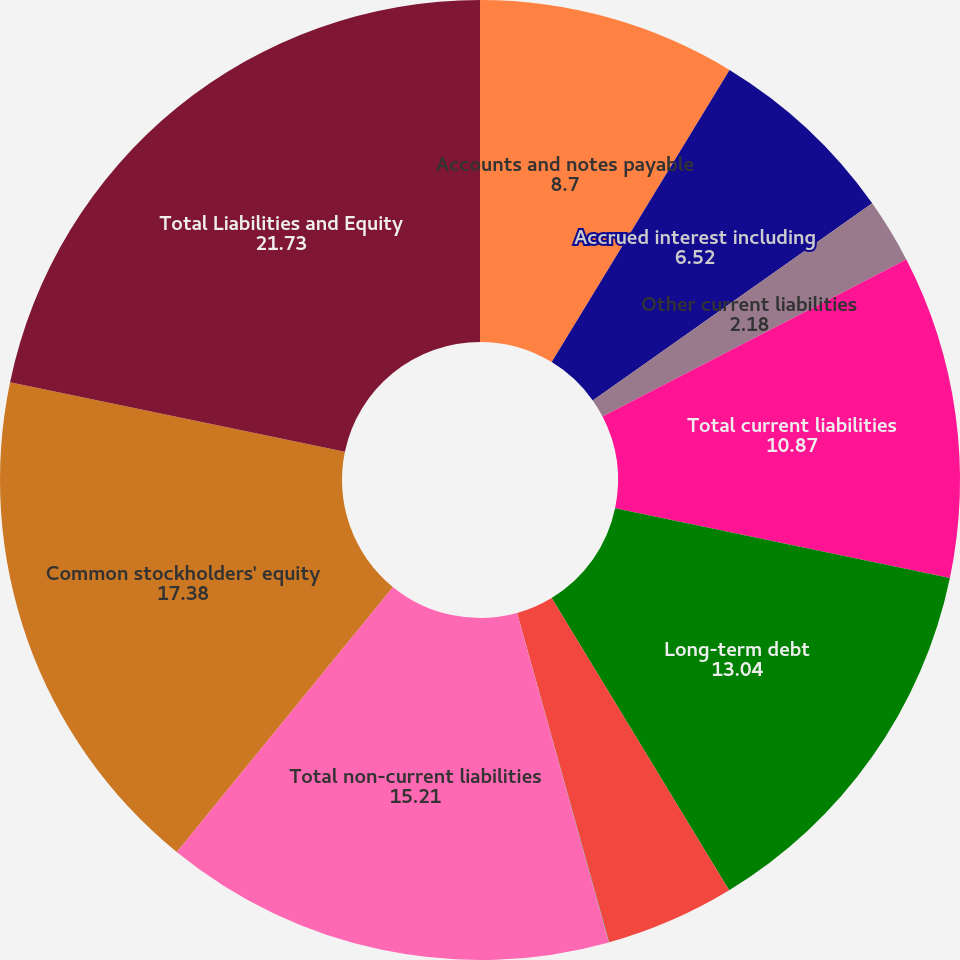Convert chart to OTSL. <chart><loc_0><loc_0><loc_500><loc_500><pie_chart><fcel>Accounts and notes payable<fcel>Accrued interest including<fcel>Other current liabilities<fcel>Total current liabilities<fcel>Long-term debt<fcel>Postretirement benefits<fcel>Other non-current liabilities<fcel>Total non-current liabilities<fcel>Common stockholders' equity<fcel>Total Liabilities and Equity<nl><fcel>8.7%<fcel>6.52%<fcel>2.18%<fcel>10.87%<fcel>13.04%<fcel>4.35%<fcel>0.01%<fcel>15.21%<fcel>17.38%<fcel>21.73%<nl></chart> 